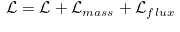Convert formula to latex. <formula><loc_0><loc_0><loc_500><loc_500>\widetilde { \mathcal { L } } = \mathcal { L } + \mathcal { L } _ { m a s s } + \mathcal { L } _ { f l u x } \\</formula> 